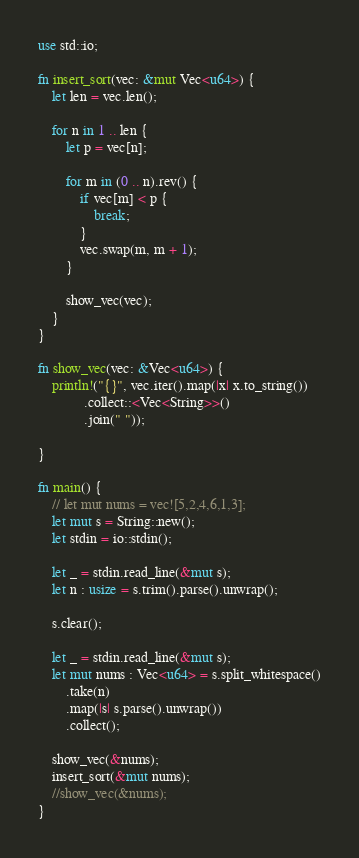<code> <loc_0><loc_0><loc_500><loc_500><_Rust_>
use std::io;

fn insert_sort(vec: &mut Vec<u64>) {
    let len = vec.len();

    for n in 1 .. len {
        let p = vec[n];

        for m in (0 .. n).rev() {
            if vec[m] < p {
                break;
            }
            vec.swap(m, m + 1);
        }

        show_vec(vec);
    }
}

fn show_vec(vec: &Vec<u64>) {
    println!("{}", vec.iter().map(|x| x.to_string())
             .collect::<Vec<String>>()
             .join(" "));
    
}

fn main() {
    // let mut nums = vec![5,2,4,6,1,3];
    let mut s = String::new();
    let stdin = io::stdin();

    let _ = stdin.read_line(&mut s);
    let n : usize = s.trim().parse().unwrap();

    s.clear();

    let _ = stdin.read_line(&mut s);
    let mut nums : Vec<u64> = s.split_whitespace()
        .take(n)
        .map(|s| s.parse().unwrap()) 
        .collect();

    show_vec(&nums);
    insert_sort(&mut nums);
    //show_vec(&nums);
}

</code> 